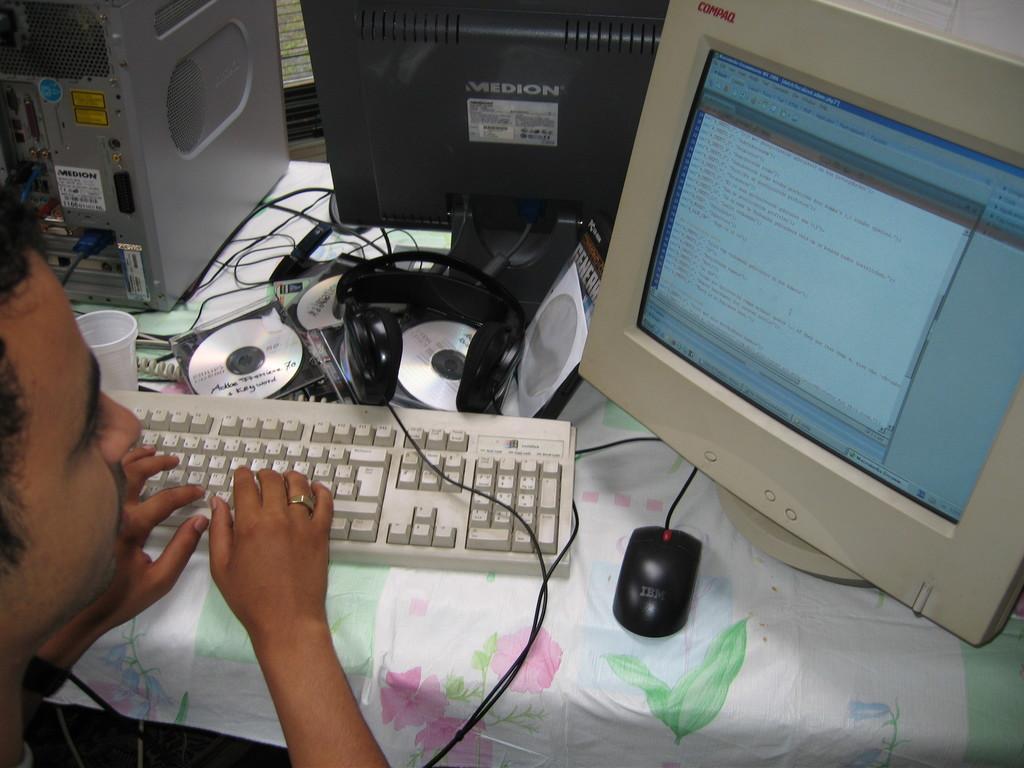In one or two sentences, can you explain what this image depicts? In this picture, we see a man. I think he is typing. In front of him, we see a table which is covered with a white color sheet. We see a monitor, headset, keyboard, mouse, glass, CDs and cables are placed on the table. 